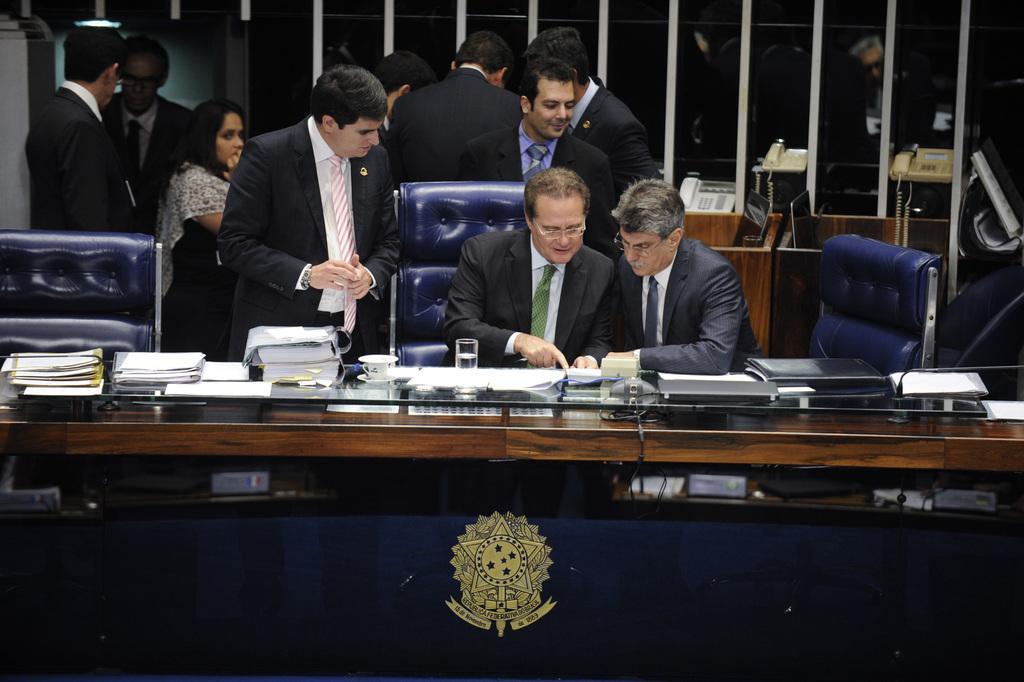How would you summarize this image in a sentence or two? In this picture there are two men in the center of the image and there are other people in the background area of the image, there is a table in front of them, on which there are books and papers, there is a rack behind them. 